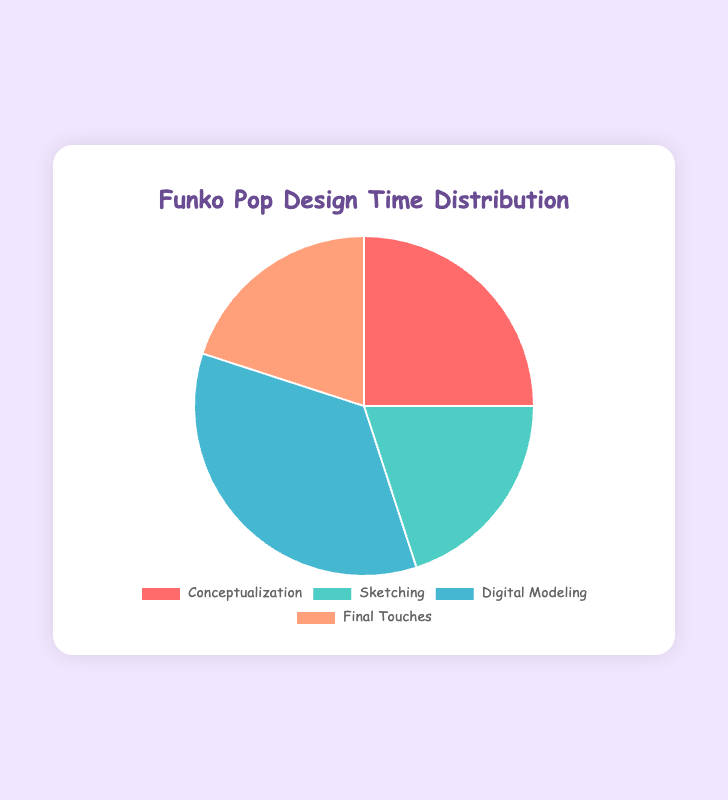What percentage of time is spent on sketching? The segment for sketching on the pie chart indicates a percentage of 20% on the visual representation.
Answer: 20% Which stage consumes the most time in the Funko Pop design process? By looking at the pie chart, the largest section is marked for "Digital Modeling" which has a percentage of 35%.
Answer: Digital Modeling How much more time is spent on Conceptualization compared to Sketching? Conceptualization takes up 25% of the time, while Sketching takes up 20%. Subtracting the two gives 25% - 20% = 5%.
Answer: 5% Are the times spent on Sketching and Final Touches equal? The pie chart shows that both Sketching and Final Touches are represented by equal segments, each with 20%.
Answer: Yes What fraction of the total design time is spent on Conceptualization and Sketching together? Conceptualization has 25% and Sketching has 20%. Adding these gives 25% + 20% = 45%.
Answer: 45% If Digital Modeling took 10% less time, would it still be the largest time-consuming stage? Digital Modeling is currently at 35%. If it took 10% less, it would be 35% - 10% = 25%. Since no other stage exceeds 25%, Digital Modeling would still share the highest time with Conceptualization.
Answer: Yes Which two stages combined account for the same percentage of time as Digital Modeling? Digital Modeling takes 35% of the time. Both Sketching and Final Touches each take 20%, so combined they total 20% + 20% = 40%. To get exactly 35%, one can combine Conceptualization (25%) and Final Touches (20%-5% for Conceptualization).
Answer: Conceptualization and Sketching Which stage is indicated by the red section in the pie chart? The red section in the pie chart corresponds to Conceptualization.
Answer: Conceptualization Is the sum of time spent on Conceptualization and Final Touches more than half of the total time? Conceptualization takes 25% and Final Touches take 20%, adding them together gives 25% + 20% = 45%, which is less than 50%.
Answer: No 